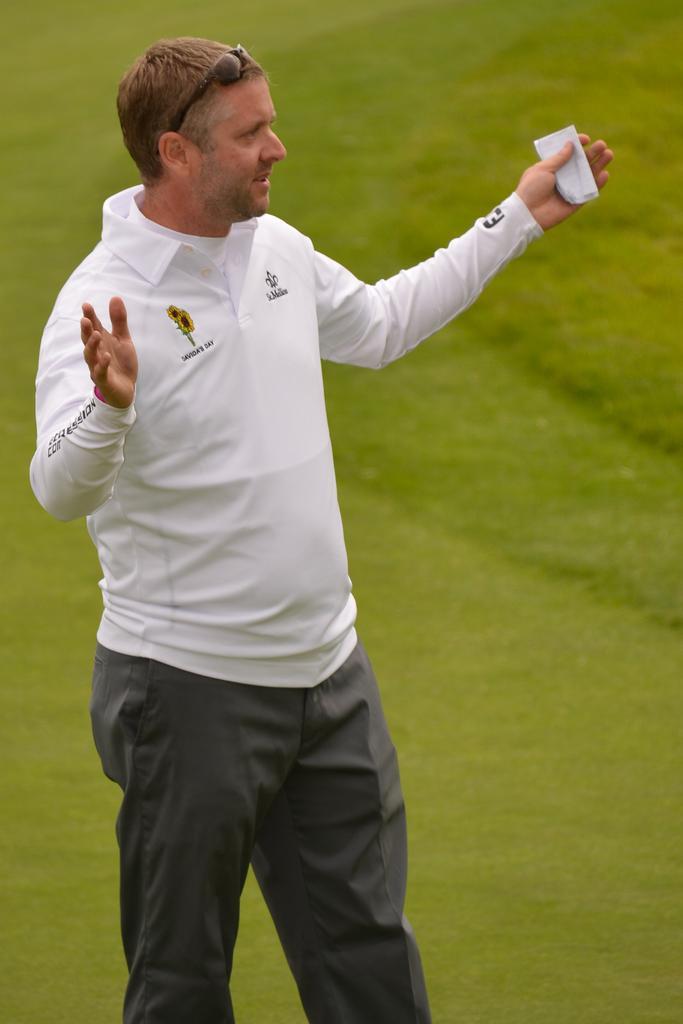In one or two sentences, can you explain what this image depicts? In this image, I can see a man standing. In the background, this is the grass. 